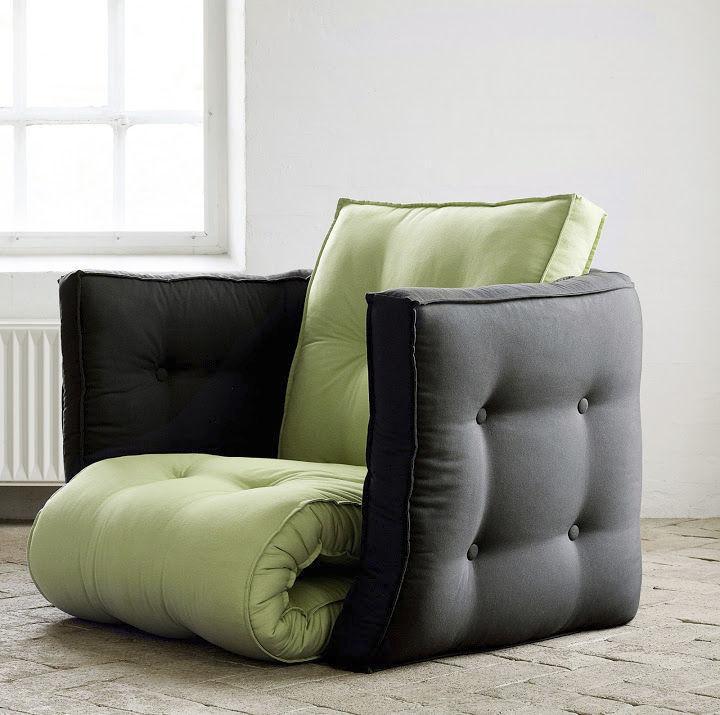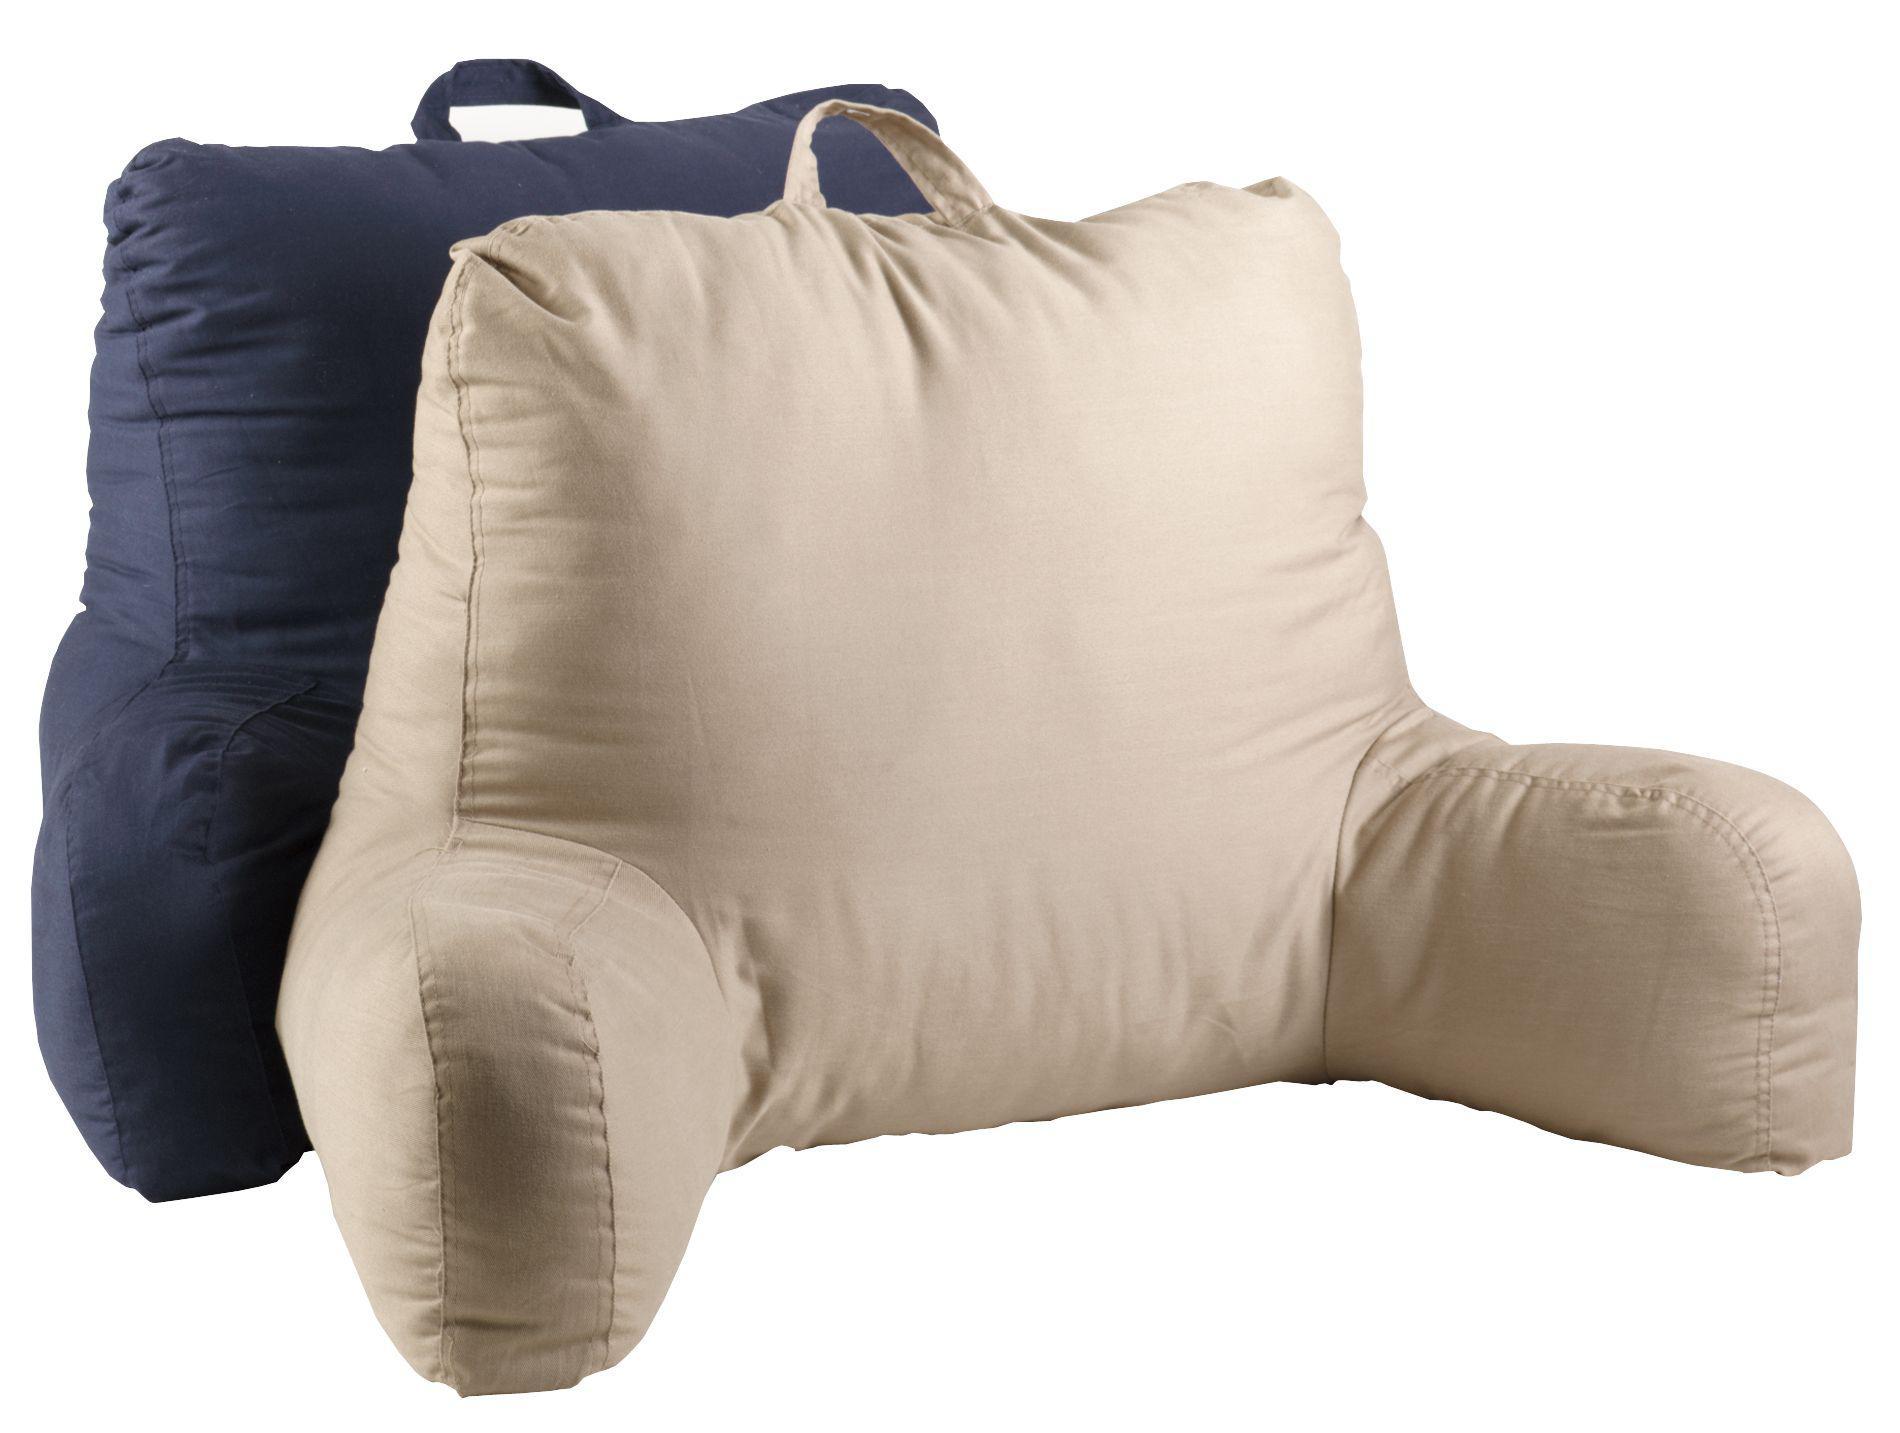The first image is the image on the left, the second image is the image on the right. Assess this claim about the two images: "At least one image features an upright bedrest with a cupholder and pouch in one arm.". Correct or not? Answer yes or no. No. The first image is the image on the left, the second image is the image on the right. Given the left and right images, does the statement "One or more images shows a backrest pillow holding a cup in a cup holder on one of the arms along with items in a side pocket" hold true? Answer yes or no. No. 